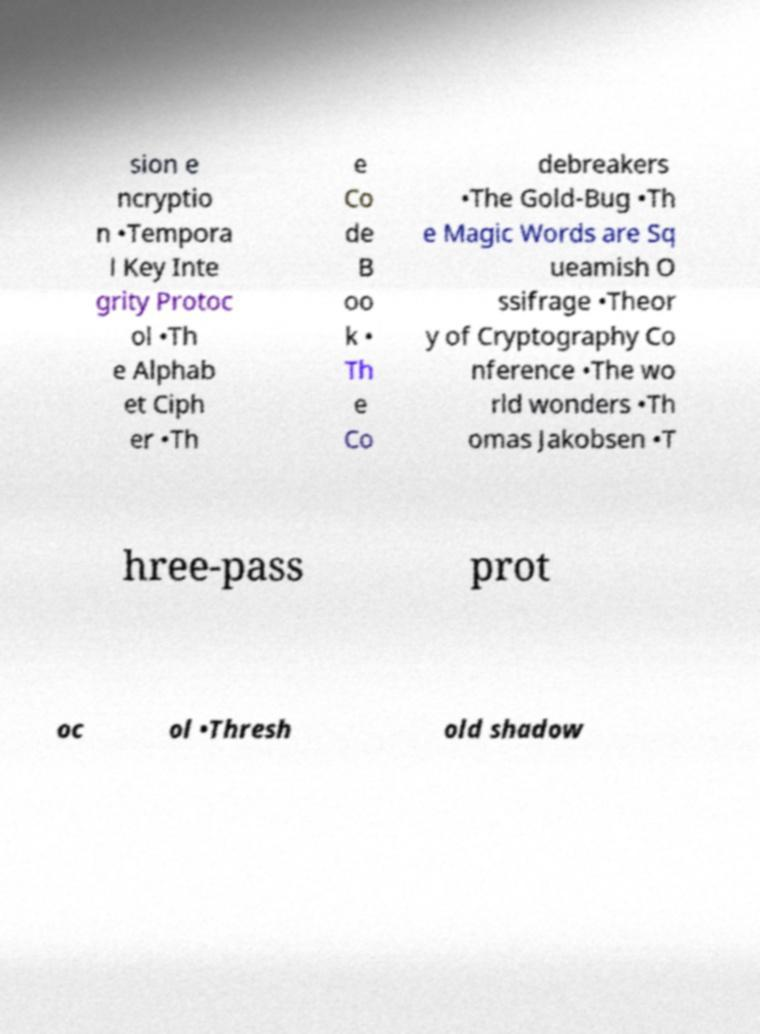For documentation purposes, I need the text within this image transcribed. Could you provide that? sion e ncryptio n •Tempora l Key Inte grity Protoc ol •Th e Alphab et Ciph er •Th e Co de B oo k • Th e Co debreakers •The Gold-Bug •Th e Magic Words are Sq ueamish O ssifrage •Theor y of Cryptography Co nference •The wo rld wonders •Th omas Jakobsen •T hree-pass prot oc ol •Thresh old shadow 